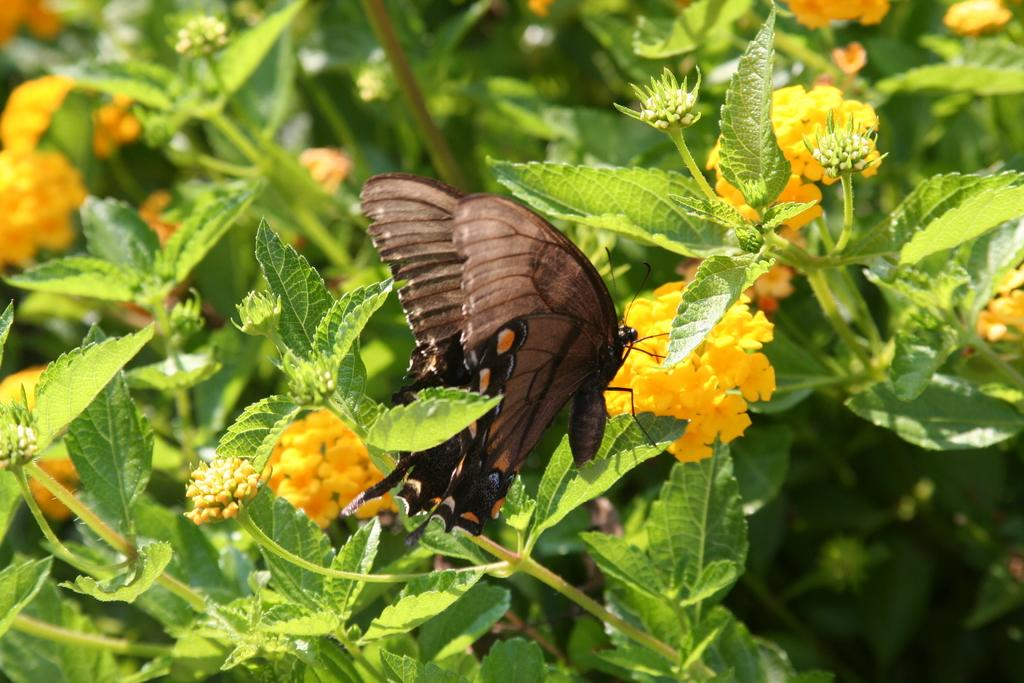What is on the leaf in the image? There is a butterfly on a leaf in the image. What type of flowers can be seen in the image? There are yellow flowers in the image. What color are the leaves in the background of the image? There are green leaves in the background of the image. Where is the camp located in the image? There is no camp present in the image. What type of shoes can be seen on the butterfly in the image? Butterflies do not wear shoes, and there are no shoes visible in the image. 